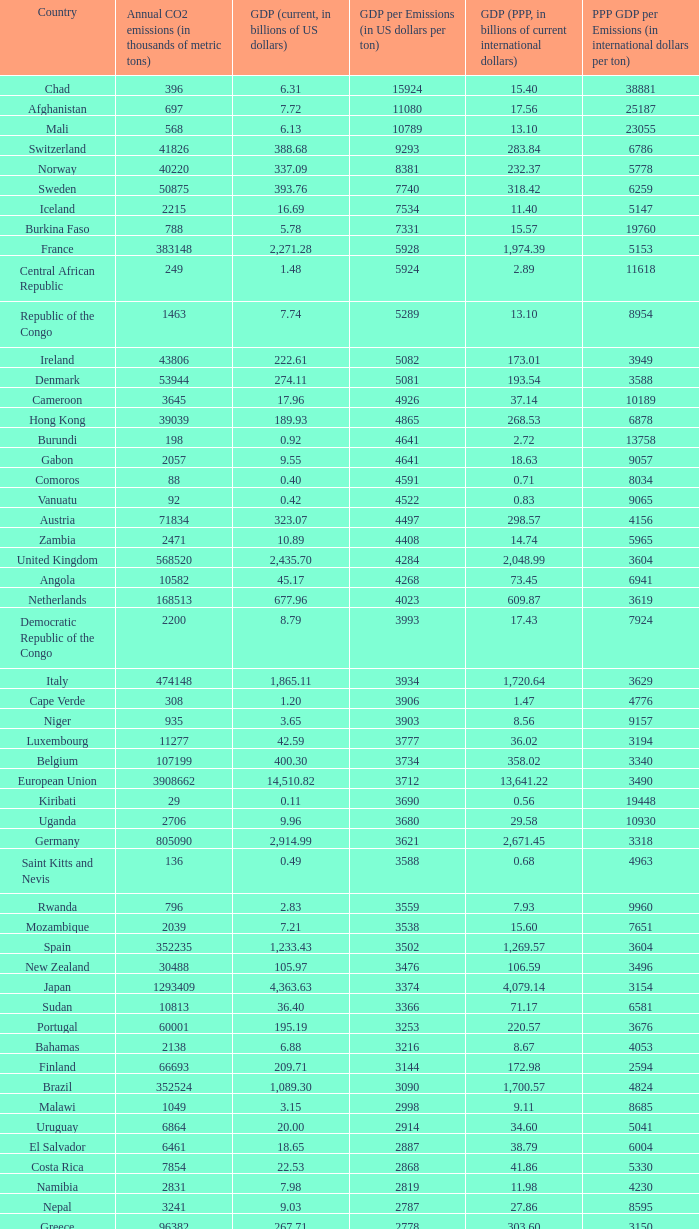When the gdp (current, in billions of us dollars) is 162.50, what is the gdp? 2562.0. 